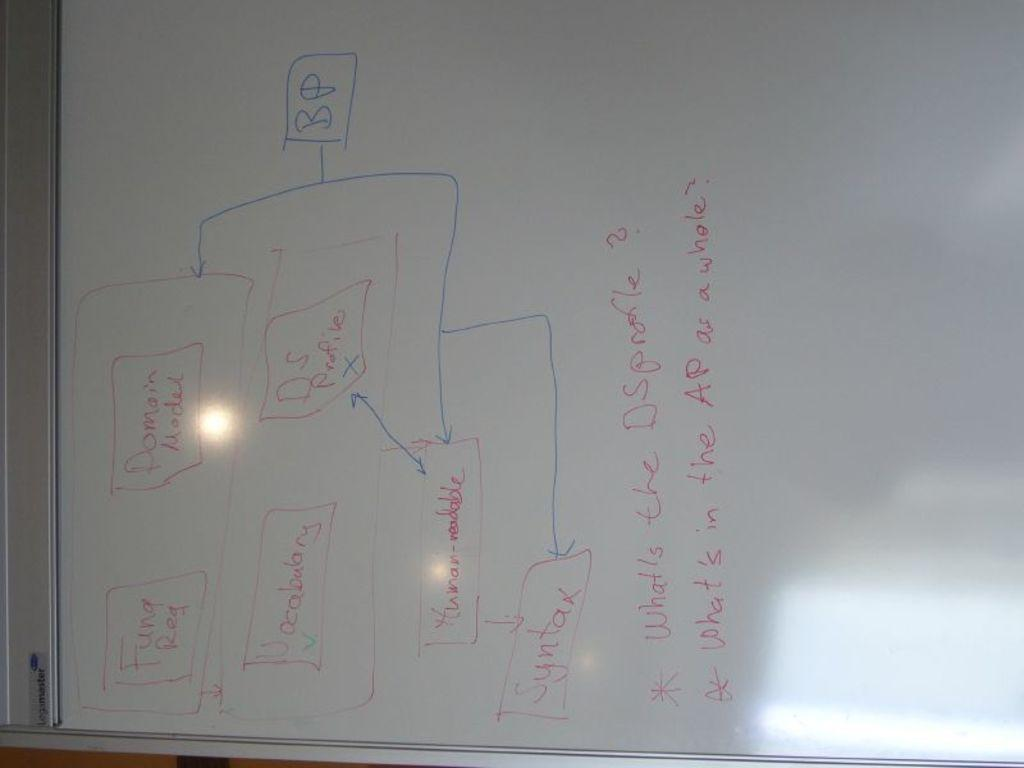<image>
Create a compact narrative representing the image presented. A whiteboard includes labels for syntax and vocabulary. 